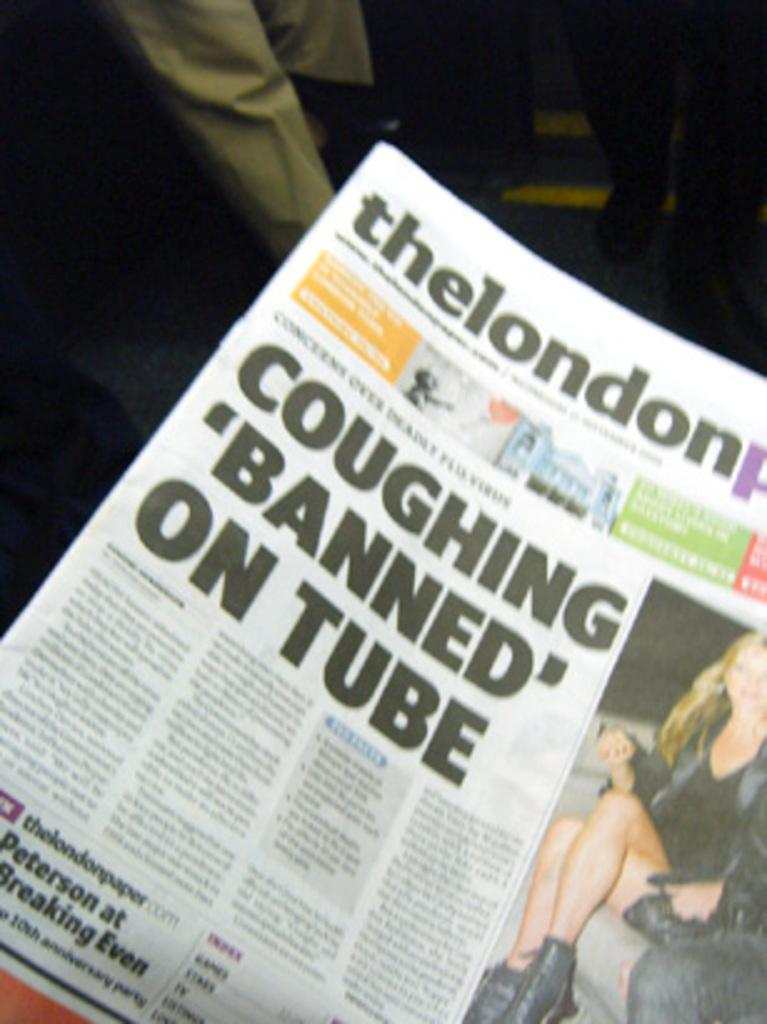What is the main object in the image? There is a newspaper in the image. What can be found within the newspaper? The newspaper contains text and an image. Can you describe the surroundings of the newspaper in the image? There are legs of persons visible in the background of the image. What type of popcorn is being served in the image? There is no popcorn present in the image. 